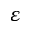Convert formula to latex. <formula><loc_0><loc_0><loc_500><loc_500>\varepsilon</formula> 